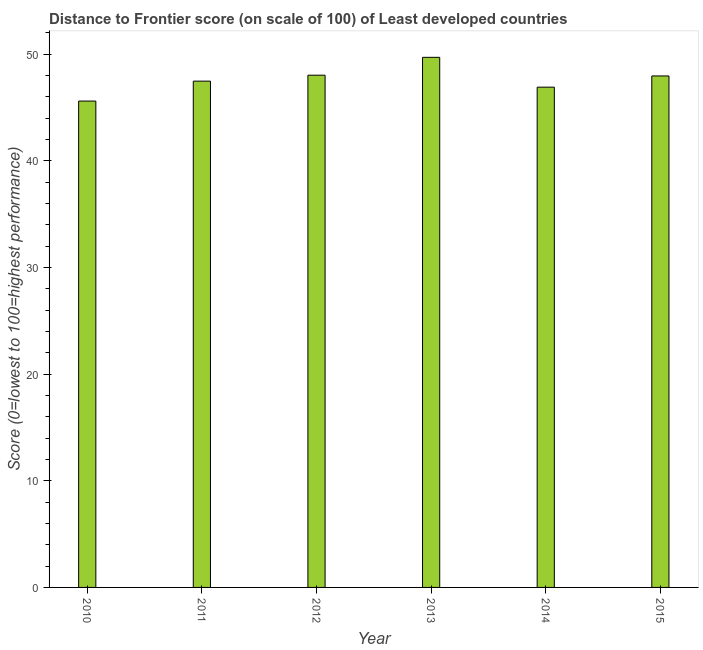What is the title of the graph?
Provide a succinct answer. Distance to Frontier score (on scale of 100) of Least developed countries. What is the label or title of the Y-axis?
Make the answer very short. Score (0=lowest to 100=highest performance). What is the distance to frontier score in 2015?
Your response must be concise. 47.96. Across all years, what is the maximum distance to frontier score?
Provide a short and direct response. 49.7. Across all years, what is the minimum distance to frontier score?
Offer a very short reply. 45.6. In which year was the distance to frontier score maximum?
Make the answer very short. 2013. In which year was the distance to frontier score minimum?
Your response must be concise. 2010. What is the sum of the distance to frontier score?
Ensure brevity in your answer.  285.66. What is the difference between the distance to frontier score in 2010 and 2014?
Your answer should be very brief. -1.3. What is the average distance to frontier score per year?
Your answer should be very brief. 47.61. What is the median distance to frontier score?
Ensure brevity in your answer.  47.71. In how many years, is the distance to frontier score greater than 6 ?
Your response must be concise. 6. What is the ratio of the distance to frontier score in 2010 to that in 2014?
Your answer should be very brief. 0.97. Is the difference between the distance to frontier score in 2011 and 2013 greater than the difference between any two years?
Provide a short and direct response. No. What is the difference between the highest and the second highest distance to frontier score?
Offer a very short reply. 1.68. What is the difference between two consecutive major ticks on the Y-axis?
Ensure brevity in your answer.  10. What is the Score (0=lowest to 100=highest performance) of 2010?
Your response must be concise. 45.6. What is the Score (0=lowest to 100=highest performance) in 2011?
Provide a short and direct response. 47.47. What is the Score (0=lowest to 100=highest performance) of 2012?
Keep it short and to the point. 48.03. What is the Score (0=lowest to 100=highest performance) of 2013?
Provide a succinct answer. 49.7. What is the Score (0=lowest to 100=highest performance) in 2014?
Make the answer very short. 46.91. What is the Score (0=lowest to 100=highest performance) in 2015?
Your answer should be very brief. 47.96. What is the difference between the Score (0=lowest to 100=highest performance) in 2010 and 2011?
Keep it short and to the point. -1.87. What is the difference between the Score (0=lowest to 100=highest performance) in 2010 and 2012?
Provide a short and direct response. -2.43. What is the difference between the Score (0=lowest to 100=highest performance) in 2010 and 2013?
Offer a terse response. -4.1. What is the difference between the Score (0=lowest to 100=highest performance) in 2010 and 2014?
Give a very brief answer. -1.3. What is the difference between the Score (0=lowest to 100=highest performance) in 2010 and 2015?
Offer a very short reply. -2.35. What is the difference between the Score (0=lowest to 100=highest performance) in 2011 and 2012?
Your answer should be very brief. -0.56. What is the difference between the Score (0=lowest to 100=highest performance) in 2011 and 2013?
Your answer should be compact. -2.23. What is the difference between the Score (0=lowest to 100=highest performance) in 2011 and 2014?
Provide a short and direct response. 0.57. What is the difference between the Score (0=lowest to 100=highest performance) in 2011 and 2015?
Provide a succinct answer. -0.49. What is the difference between the Score (0=lowest to 100=highest performance) in 2012 and 2013?
Give a very brief answer. -1.68. What is the difference between the Score (0=lowest to 100=highest performance) in 2012 and 2014?
Give a very brief answer. 1.12. What is the difference between the Score (0=lowest to 100=highest performance) in 2012 and 2015?
Make the answer very short. 0.07. What is the difference between the Score (0=lowest to 100=highest performance) in 2013 and 2014?
Ensure brevity in your answer.  2.8. What is the difference between the Score (0=lowest to 100=highest performance) in 2013 and 2015?
Ensure brevity in your answer.  1.75. What is the difference between the Score (0=lowest to 100=highest performance) in 2014 and 2015?
Offer a very short reply. -1.05. What is the ratio of the Score (0=lowest to 100=highest performance) in 2010 to that in 2012?
Make the answer very short. 0.95. What is the ratio of the Score (0=lowest to 100=highest performance) in 2010 to that in 2013?
Your answer should be compact. 0.92. What is the ratio of the Score (0=lowest to 100=highest performance) in 2010 to that in 2014?
Make the answer very short. 0.97. What is the ratio of the Score (0=lowest to 100=highest performance) in 2010 to that in 2015?
Your answer should be very brief. 0.95. What is the ratio of the Score (0=lowest to 100=highest performance) in 2011 to that in 2013?
Make the answer very short. 0.95. What is the ratio of the Score (0=lowest to 100=highest performance) in 2011 to that in 2014?
Offer a very short reply. 1.01. What is the ratio of the Score (0=lowest to 100=highest performance) in 2011 to that in 2015?
Offer a very short reply. 0.99. What is the ratio of the Score (0=lowest to 100=highest performance) in 2012 to that in 2013?
Your answer should be very brief. 0.97. What is the ratio of the Score (0=lowest to 100=highest performance) in 2013 to that in 2014?
Your response must be concise. 1.06. What is the ratio of the Score (0=lowest to 100=highest performance) in 2013 to that in 2015?
Provide a short and direct response. 1.04. 